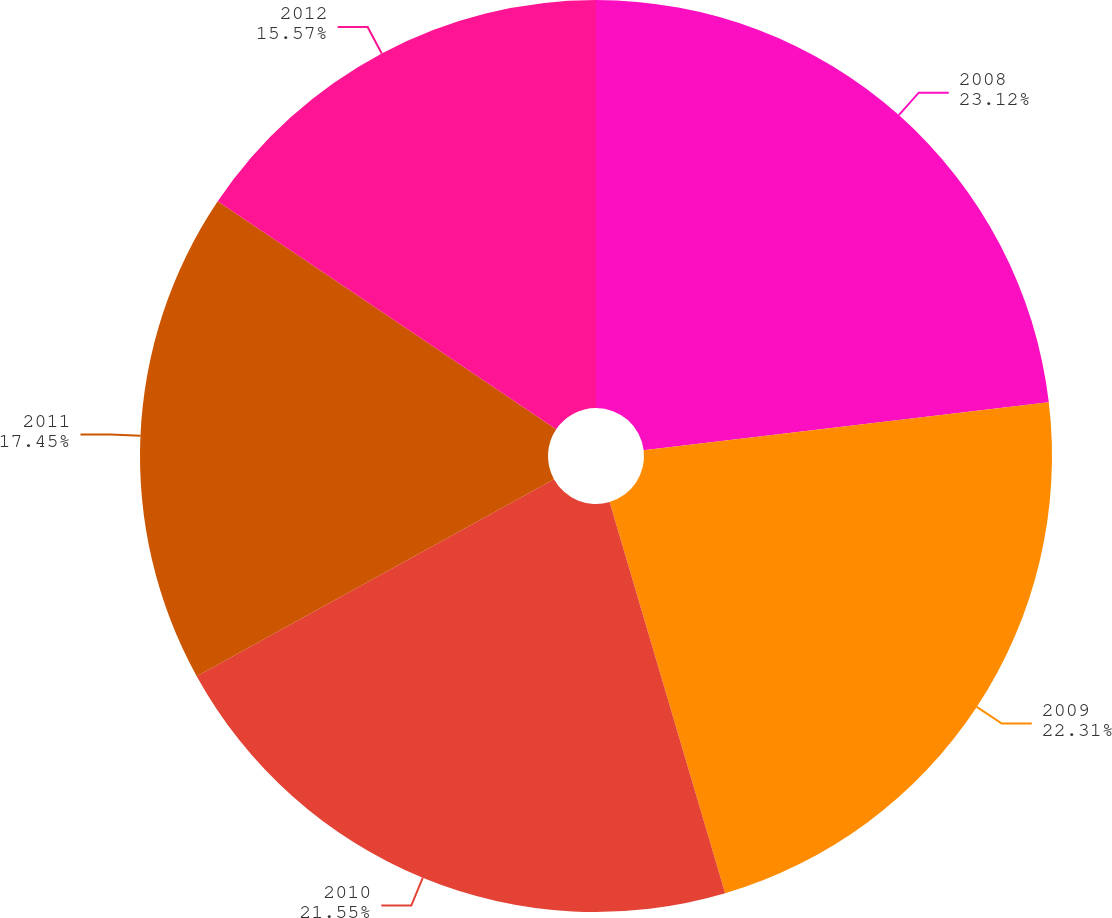Convert chart to OTSL. <chart><loc_0><loc_0><loc_500><loc_500><pie_chart><fcel>2008<fcel>2009<fcel>2010<fcel>2011<fcel>2012<nl><fcel>23.12%<fcel>22.31%<fcel>21.55%<fcel>17.45%<fcel>15.57%<nl></chart> 